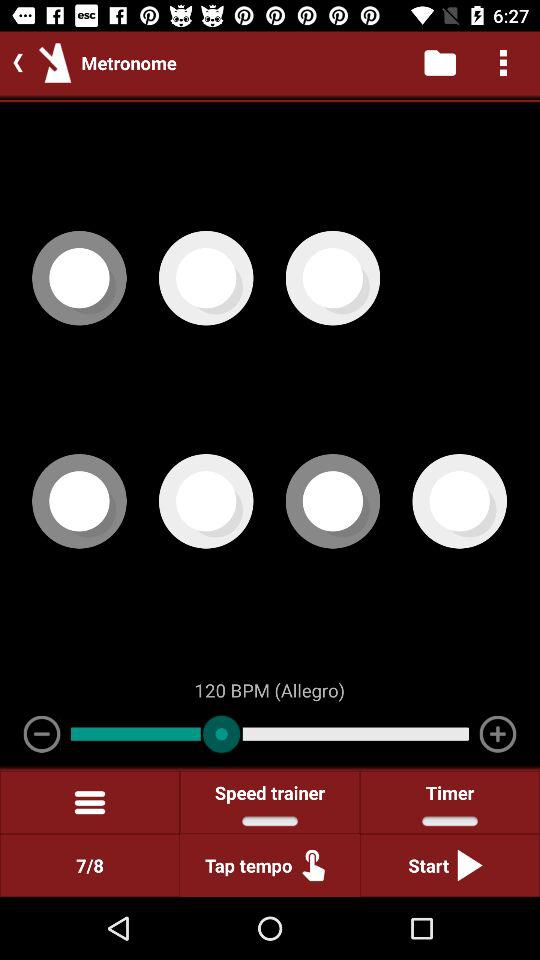What is the selected "BPM"? The selected "BPM" is 120. 